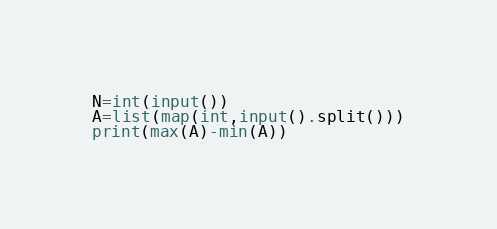<code> <loc_0><loc_0><loc_500><loc_500><_Python_>N=int(input())
A=list(map(int,input().split()))
print(max(A)-min(A))</code> 